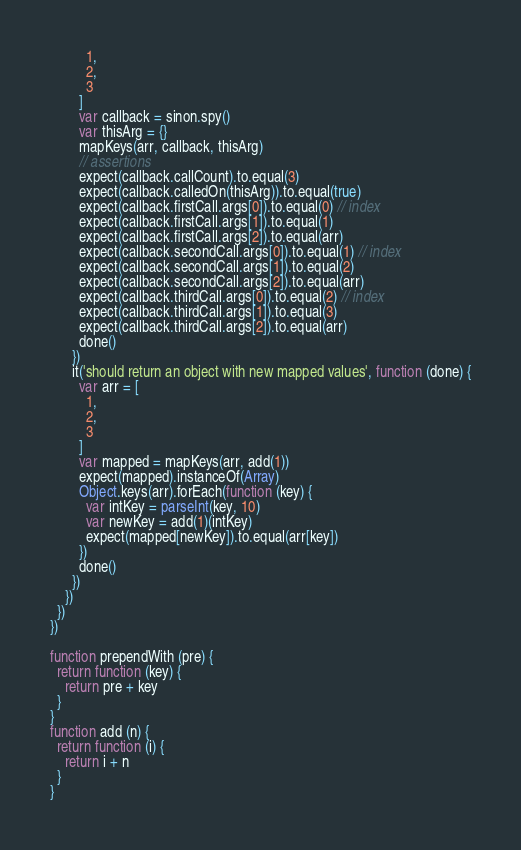<code> <loc_0><loc_0><loc_500><loc_500><_JavaScript_>          1,
          2,
          3
        ]
        var callback = sinon.spy()
        var thisArg = {}
        mapKeys(arr, callback, thisArg)
        // assertions
        expect(callback.callCount).to.equal(3)
        expect(callback.calledOn(thisArg)).to.equal(true)
        expect(callback.firstCall.args[0]).to.equal(0) // index
        expect(callback.firstCall.args[1]).to.equal(1)
        expect(callback.firstCall.args[2]).to.equal(arr)
        expect(callback.secondCall.args[0]).to.equal(1) // index
        expect(callback.secondCall.args[1]).to.equal(2)
        expect(callback.secondCall.args[2]).to.equal(arr)
        expect(callback.thirdCall.args[0]).to.equal(2) // index
        expect(callback.thirdCall.args[1]).to.equal(3)
        expect(callback.thirdCall.args[2]).to.equal(arr)
        done()
      })
      it('should return an object with new mapped values', function (done) {
        var arr = [
          1,
          2,
          3
        ]
        var mapped = mapKeys(arr, add(1))
        expect(mapped).instanceOf(Array)
        Object.keys(arr).forEach(function (key) {
          var intKey = parseInt(key, 10)
          var newKey = add(1)(intKey)
          expect(mapped[newKey]).to.equal(arr[key])
        })
        done()
      })
    })
  })
})

function prependWith (pre) {
  return function (key) {
    return pre + key
  }
}
function add (n) {
  return function (i) {
    return i + n
  }
}
</code> 